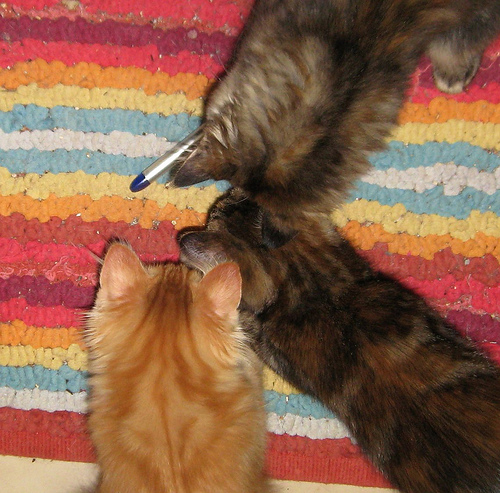<image>
Is the cat on the rainbow rug? Yes. Looking at the image, I can see the cat is positioned on top of the rainbow rug, with the rainbow rug providing support. 